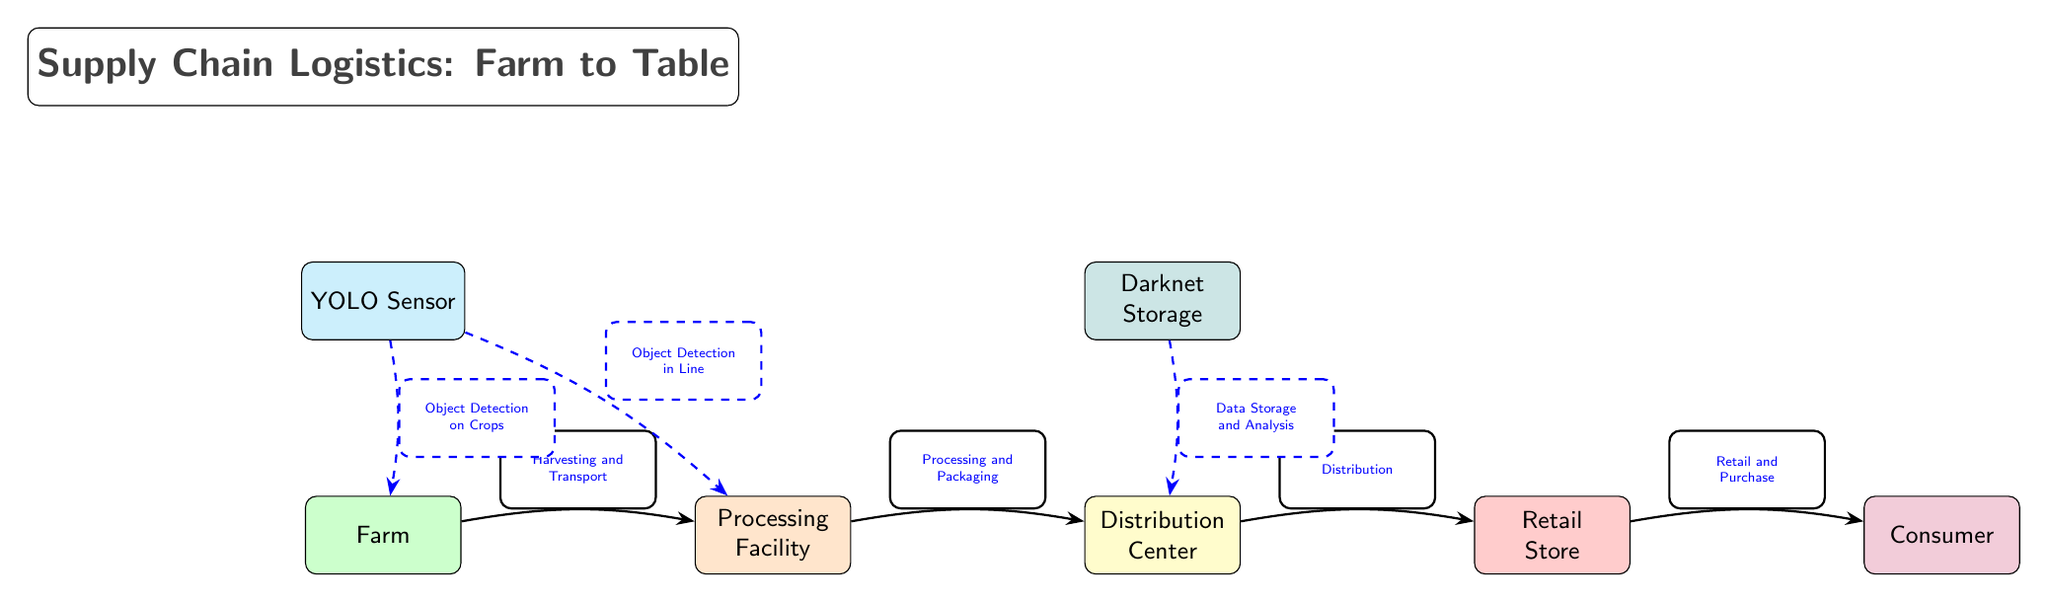What are the nodes in the supply chain? The diagram includes five main nodes: Farm, Processing Facility, Distribution Center, Retail Store, and Consumer.
Answer: Farm, Processing Facility, Distribution Center, Retail Store, Consumer What is the first process in the supply chain? The first process indicated in the diagram is "Harvesting and Transport," which connects the Farm to the Processing Facility.
Answer: Harvesting and Transport How many edges are there in the diagram? By counting, there are four main directed edges connecting the five nodes, resulting in a total of four edges.
Answer: 4 What kind of sensor is represented above the Farm? The diagram shows a "YOLO Sensor" above the Farm node, indicating its role in monitoring crops.
Answer: YOLO Sensor What is the purpose of the dashed edges in the diagram? The dashed edges indicate additional functionalities related to the YOLO Sensor and Darknet Storage, such as object detection and data storage.
Answer: Object Detection and Data Storage Which node is associated with object detection in the processing phase? The diagram states that object detection occurs "in Line" during the Processing phase, connected by a dashed edge from the YOLO Sensor.
Answer: Processing Between which two nodes does the distribution process occur? The distribution process occurs between the Distribution Center and the Retail Store, as indicated by the edge labeled "Distribution."
Answer: Distribution Center and Retail Store What is the color associated with the Consumer node? The Consumer node is represented in purple, as shown in the diagram.
Answer: Purple What connects the Distribution Center to the Retail Store? The edge labeled "Distribution" connects the Distribution Center to the Retail Store, highlighting the flow of products.
Answer: Distribution What does the Darknet node indicate about data handling? The Darknet node indicates "Data Storage and Analysis," suggesting it plays a role in managing and analyzing distribution data.
Answer: Data Storage and Analysis 